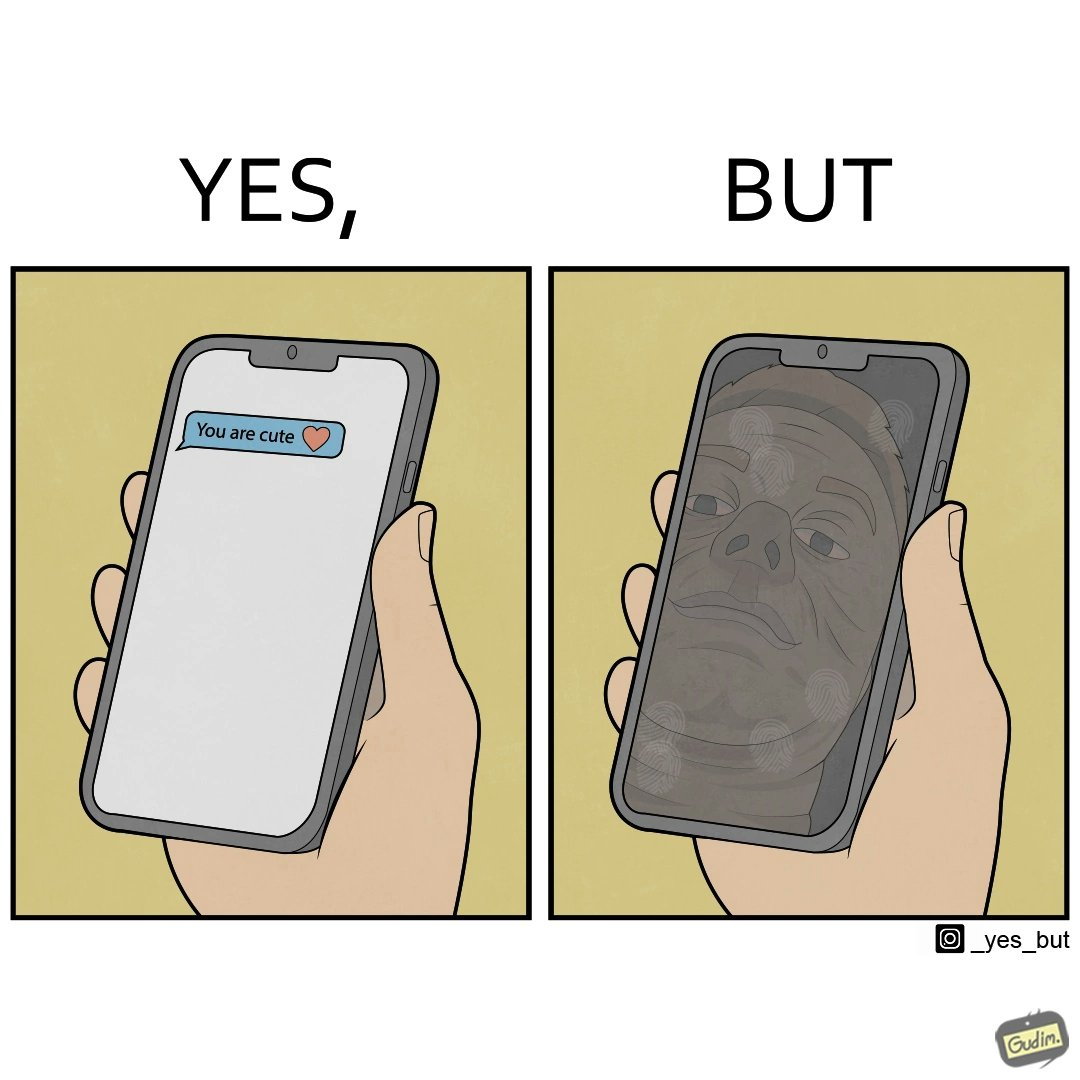What makes this image funny or satirical? The image is ironic, because person who received the text saying "you are cute" is apparently not good looking according to the beautyÃÂ standards 